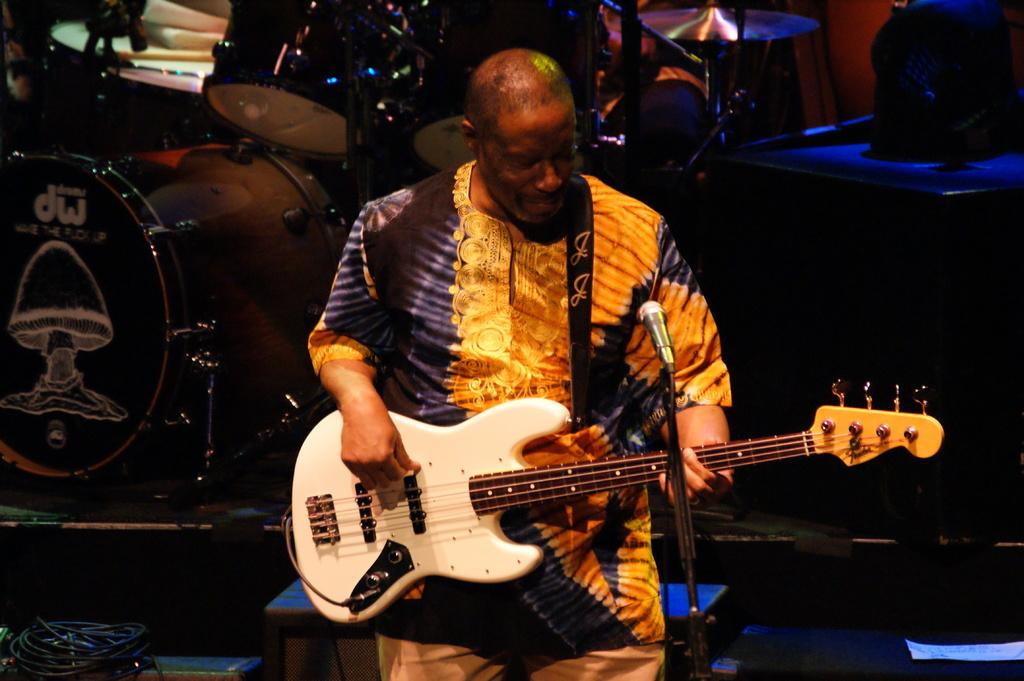Who is the main subject in the image? There is a man in the image. What is the man holding in the image? The man is holding a guitar. What else can be seen in the image related to music? There are musical instruments visible behind the man. What type of egg is the man using to play the guitar in the image? There is no egg present in the image, and the man is not using any egg to play the guitar. 